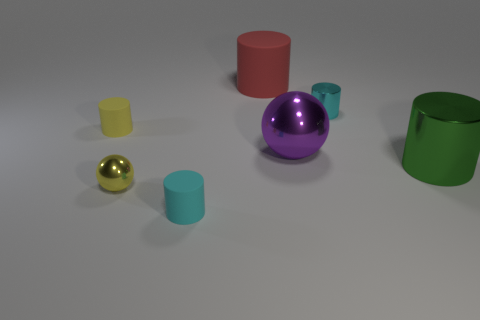Add 1 small yellow matte cylinders. How many objects exist? 8 Subtract all big cylinders. How many cylinders are left? 3 Subtract 2 balls. How many balls are left? 0 Subtract all cyan cylinders. How many cylinders are left? 3 Subtract all balls. How many objects are left? 5 Add 5 small blue matte spheres. How many small blue matte spheres exist? 5 Subtract 0 brown blocks. How many objects are left? 7 Subtract all green spheres. Subtract all green blocks. How many spheres are left? 2 Subtract all yellow cubes. How many red cylinders are left? 1 Subtract all tiny cyan cylinders. Subtract all large objects. How many objects are left? 2 